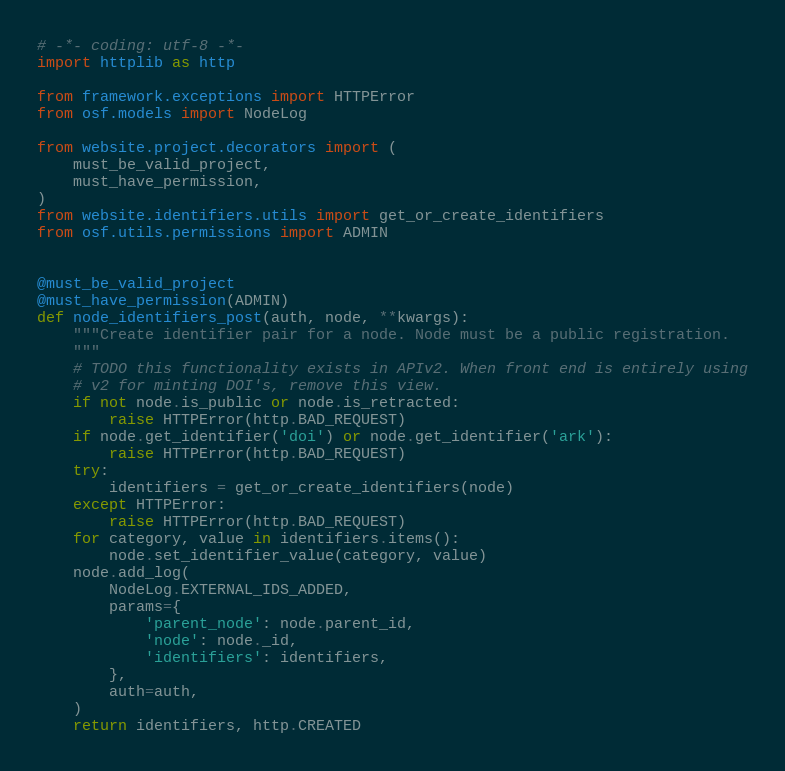Convert code to text. <code><loc_0><loc_0><loc_500><loc_500><_Python_># -*- coding: utf-8 -*-
import httplib as http

from framework.exceptions import HTTPError
from osf.models import NodeLog

from website.project.decorators import (
    must_be_valid_project,
    must_have_permission,
)
from website.identifiers.utils import get_or_create_identifiers
from osf.utils.permissions import ADMIN


@must_be_valid_project
@must_have_permission(ADMIN)
def node_identifiers_post(auth, node, **kwargs):
    """Create identifier pair for a node. Node must be a public registration.
    """
    # TODO this functionality exists in APIv2. When front end is entirely using
    # v2 for minting DOI's, remove this view.
    if not node.is_public or node.is_retracted:
        raise HTTPError(http.BAD_REQUEST)
    if node.get_identifier('doi') or node.get_identifier('ark'):
        raise HTTPError(http.BAD_REQUEST)
    try:
        identifiers = get_or_create_identifiers(node)
    except HTTPError:
        raise HTTPError(http.BAD_REQUEST)
    for category, value in identifiers.items():
        node.set_identifier_value(category, value)
    node.add_log(
        NodeLog.EXTERNAL_IDS_ADDED,
        params={
            'parent_node': node.parent_id,
            'node': node._id,
            'identifiers': identifiers,
        },
        auth=auth,
    )
    return identifiers, http.CREATED
</code> 